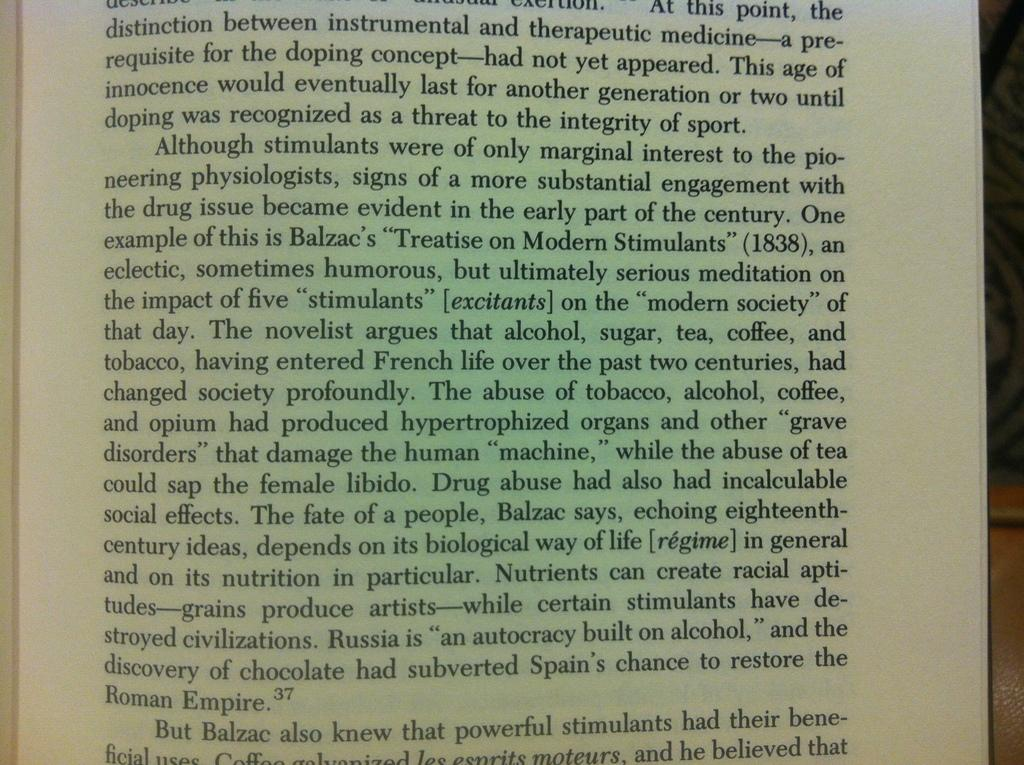<image>
Create a compact narrative representing the image presented. A book page has information about Balzac and includes footnote number 37. 